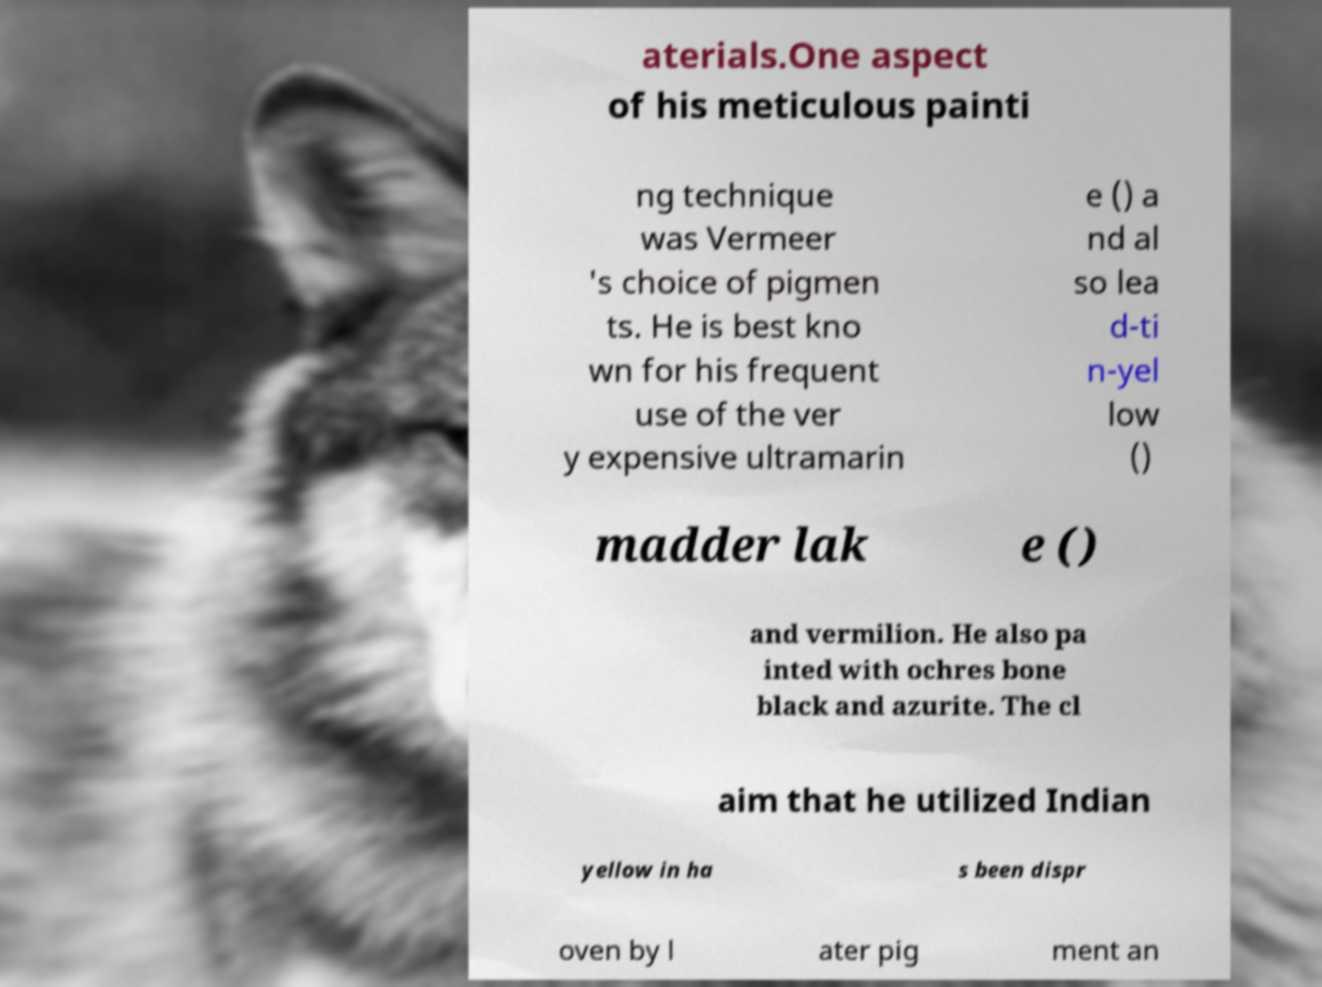What messages or text are displayed in this image? I need them in a readable, typed format. aterials.One aspect of his meticulous painti ng technique was Vermeer 's choice of pigmen ts. He is best kno wn for his frequent use of the ver y expensive ultramarin e () a nd al so lea d-ti n-yel low () madder lak e () and vermilion. He also pa inted with ochres bone black and azurite. The cl aim that he utilized Indian yellow in ha s been dispr oven by l ater pig ment an 